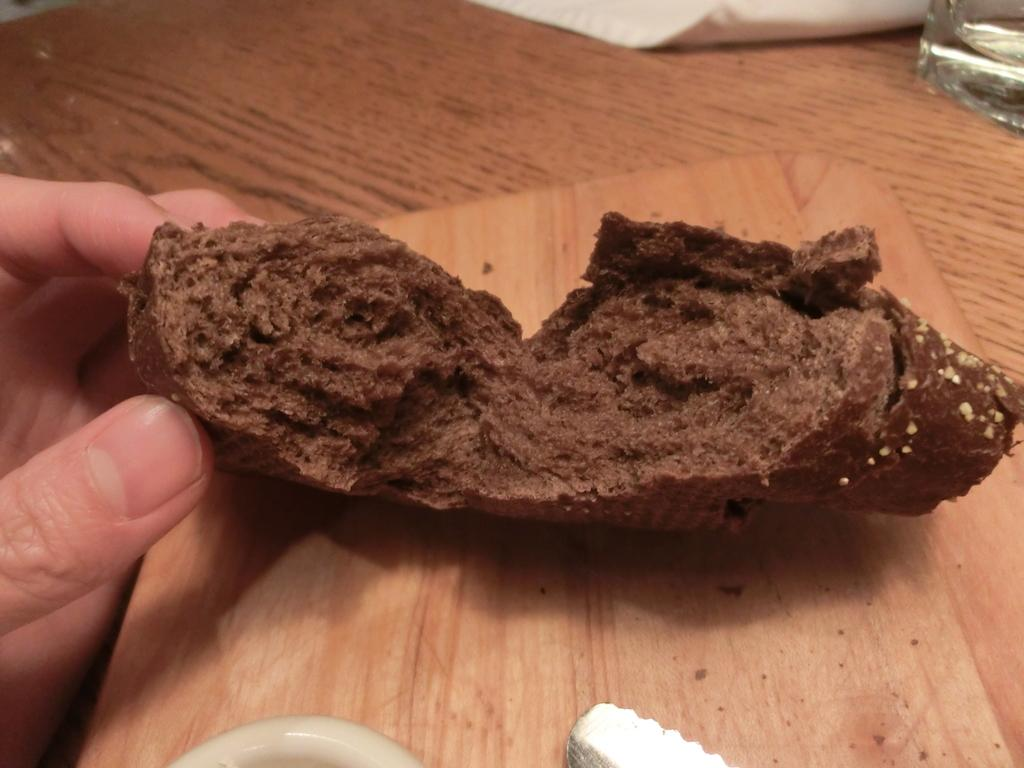What is on the table in the image? There is a chopping board and a food item that looks like a cake on the table. What is the person in the image doing with the cake? A person's hand is holding the cake. What else can be seen on the table besides the chopping board and cake? There are additional objects on the table. Is the person's grandmother helping them with the cake in the image? There is no indication of a grandmother or any other person in the image besides the hand holding the cake. Where is the cake being taken on a voyage in the image? There is no indication of a cake being taken on a voyage in the image; it is simply being held by a hand. 